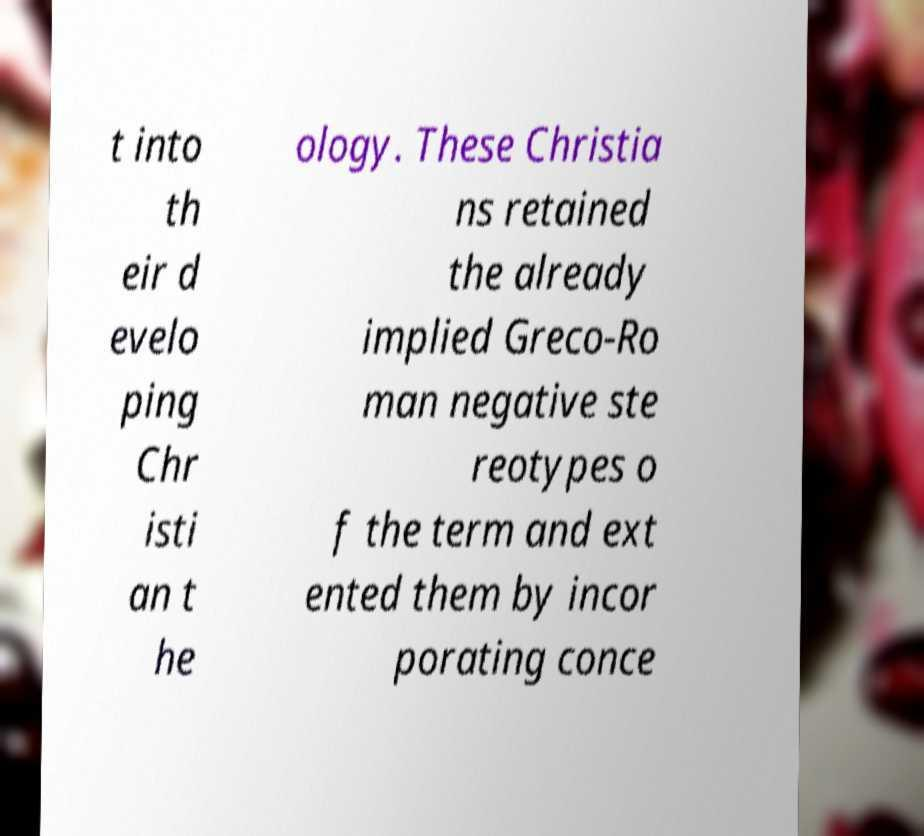Please identify and transcribe the text found in this image. t into th eir d evelo ping Chr isti an t he ology. These Christia ns retained the already implied Greco-Ro man negative ste reotypes o f the term and ext ented them by incor porating conce 